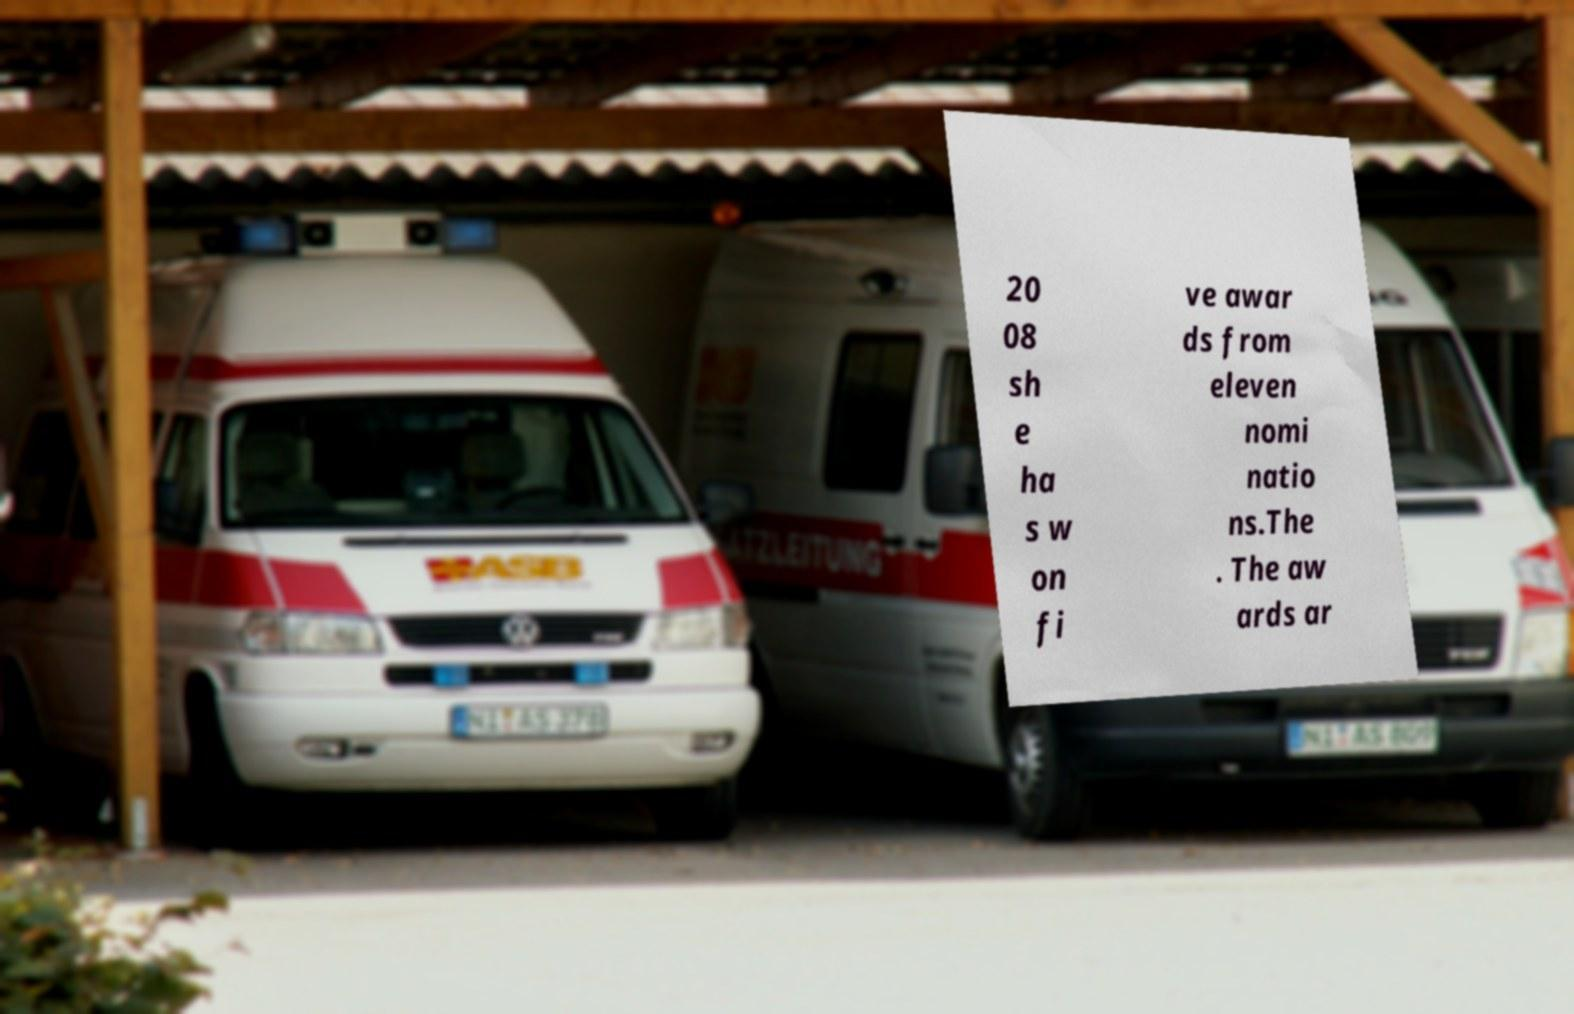What messages or text are displayed in this image? I need them in a readable, typed format. 20 08 sh e ha s w on fi ve awar ds from eleven nomi natio ns.The . The aw ards ar 